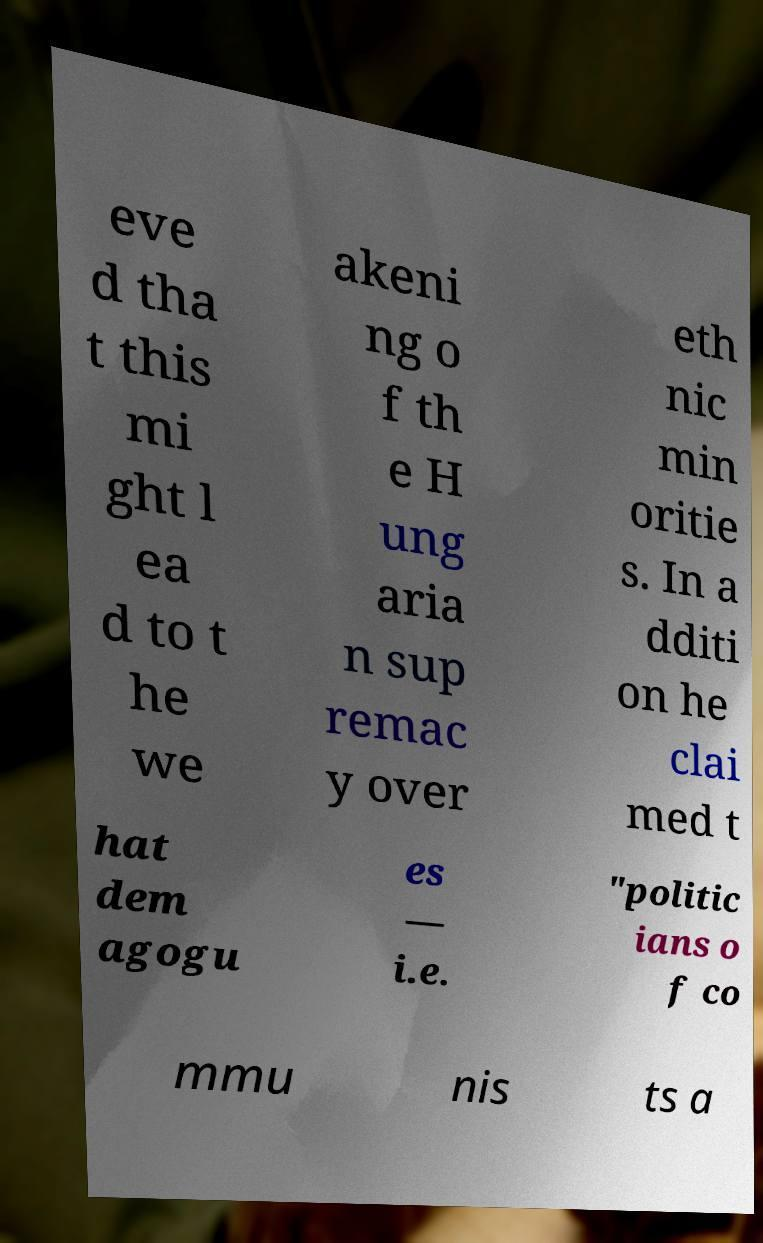Can you accurately transcribe the text from the provided image for me? eve d tha t this mi ght l ea d to t he we akeni ng o f th e H ung aria n sup remac y over eth nic min oritie s. In a dditi on he clai med t hat dem agogu es — i.e. "politic ians o f co mmu nis ts a 